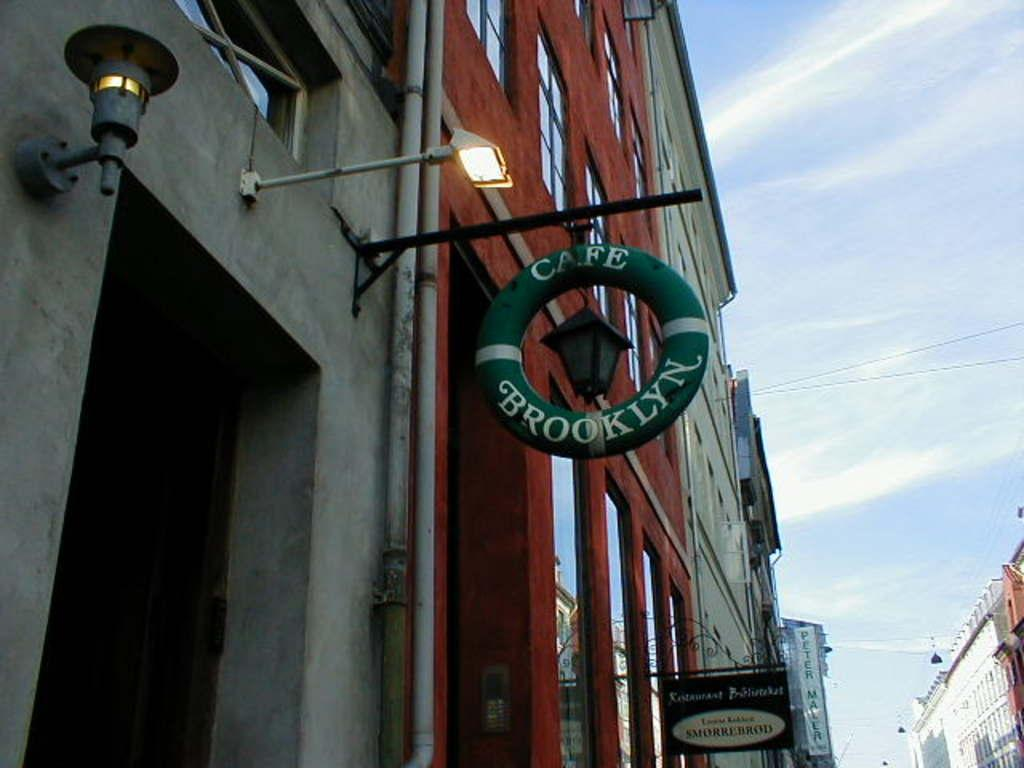What type of structures are present in the image? There are buildings in the image. What feature do the buildings have? The buildings have glass windows. What else can be seen on the buildings? There are signboards on the buildings. What are the light-poles used for in the image? The light-poles are used for illumination in the image. What is the color of the sky in the image? The sky is blue and white in color. Can you describe the action of the cats in the image? There are no cats present in the image, so there is no action involving cats to describe. 